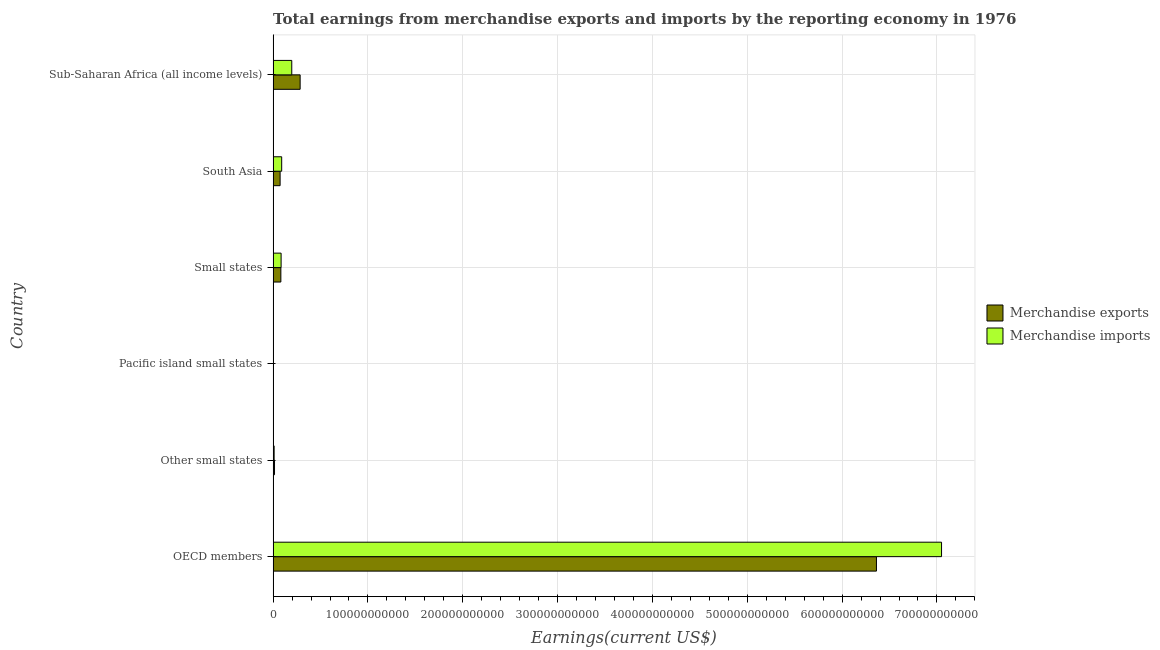How many different coloured bars are there?
Keep it short and to the point. 2. Are the number of bars per tick equal to the number of legend labels?
Make the answer very short. Yes. How many bars are there on the 5th tick from the bottom?
Ensure brevity in your answer.  2. In how many cases, is the number of bars for a given country not equal to the number of legend labels?
Your answer should be compact. 0. What is the earnings from merchandise imports in Small states?
Your answer should be compact. 8.42e+09. Across all countries, what is the maximum earnings from merchandise imports?
Offer a terse response. 7.05e+11. Across all countries, what is the minimum earnings from merchandise exports?
Offer a terse response. 1.87e+08. In which country was the earnings from merchandise imports minimum?
Offer a very short reply. Pacific island small states. What is the total earnings from merchandise exports in the graph?
Keep it short and to the point. 6.82e+11. What is the difference between the earnings from merchandise imports in OECD members and that in South Asia?
Ensure brevity in your answer.  6.96e+11. What is the difference between the earnings from merchandise imports in South Asia and the earnings from merchandise exports in Sub-Saharan Africa (all income levels)?
Provide a succinct answer. -1.95e+1. What is the average earnings from merchandise imports per country?
Provide a short and direct response. 1.24e+11. What is the difference between the earnings from merchandise imports and earnings from merchandise exports in Sub-Saharan Africa (all income levels)?
Ensure brevity in your answer.  -8.84e+09. In how many countries, is the earnings from merchandise imports greater than 280000000000 US$?
Offer a very short reply. 1. What is the ratio of the earnings from merchandise exports in Other small states to that in Sub-Saharan Africa (all income levels)?
Offer a very short reply. 0.05. Is the earnings from merchandise imports in OECD members less than that in Small states?
Your answer should be compact. No. What is the difference between the highest and the second highest earnings from merchandise exports?
Your answer should be compact. 6.08e+11. What is the difference between the highest and the lowest earnings from merchandise exports?
Your response must be concise. 6.36e+11. In how many countries, is the earnings from merchandise imports greater than the average earnings from merchandise imports taken over all countries?
Offer a terse response. 1. Is the sum of the earnings from merchandise imports in Pacific island small states and Small states greater than the maximum earnings from merchandise exports across all countries?
Your answer should be very brief. No. What does the 2nd bar from the top in South Asia represents?
Provide a short and direct response. Merchandise exports. What does the 2nd bar from the bottom in South Asia represents?
Your response must be concise. Merchandise imports. How many bars are there?
Keep it short and to the point. 12. Are all the bars in the graph horizontal?
Give a very brief answer. Yes. What is the difference between two consecutive major ticks on the X-axis?
Your answer should be compact. 1.00e+11. Does the graph contain any zero values?
Provide a succinct answer. No. How many legend labels are there?
Give a very brief answer. 2. What is the title of the graph?
Ensure brevity in your answer.  Total earnings from merchandise exports and imports by the reporting economy in 1976. Does "Non-resident workers" appear as one of the legend labels in the graph?
Ensure brevity in your answer.  No. What is the label or title of the X-axis?
Give a very brief answer. Earnings(current US$). What is the label or title of the Y-axis?
Offer a very short reply. Country. What is the Earnings(current US$) of Merchandise exports in OECD members?
Your answer should be very brief. 6.36e+11. What is the Earnings(current US$) in Merchandise imports in OECD members?
Make the answer very short. 7.05e+11. What is the Earnings(current US$) of Merchandise exports in Other small states?
Offer a very short reply. 1.46e+09. What is the Earnings(current US$) of Merchandise imports in Other small states?
Make the answer very short. 1.07e+09. What is the Earnings(current US$) of Merchandise exports in Pacific island small states?
Your answer should be very brief. 1.87e+08. What is the Earnings(current US$) of Merchandise imports in Pacific island small states?
Keep it short and to the point. 3.20e+08. What is the Earnings(current US$) of Merchandise exports in Small states?
Offer a very short reply. 8.16e+09. What is the Earnings(current US$) in Merchandise imports in Small states?
Give a very brief answer. 8.42e+09. What is the Earnings(current US$) in Merchandise exports in South Asia?
Provide a succinct answer. 7.37e+09. What is the Earnings(current US$) in Merchandise imports in South Asia?
Keep it short and to the point. 9.03e+09. What is the Earnings(current US$) in Merchandise exports in Sub-Saharan Africa (all income levels)?
Ensure brevity in your answer.  2.85e+1. What is the Earnings(current US$) of Merchandise imports in Sub-Saharan Africa (all income levels)?
Make the answer very short. 1.97e+1. Across all countries, what is the maximum Earnings(current US$) of Merchandise exports?
Provide a short and direct response. 6.36e+11. Across all countries, what is the maximum Earnings(current US$) of Merchandise imports?
Your answer should be very brief. 7.05e+11. Across all countries, what is the minimum Earnings(current US$) of Merchandise exports?
Your response must be concise. 1.87e+08. Across all countries, what is the minimum Earnings(current US$) in Merchandise imports?
Offer a very short reply. 3.20e+08. What is the total Earnings(current US$) of Merchandise exports in the graph?
Keep it short and to the point. 6.82e+11. What is the total Earnings(current US$) of Merchandise imports in the graph?
Give a very brief answer. 7.43e+11. What is the difference between the Earnings(current US$) in Merchandise exports in OECD members and that in Other small states?
Give a very brief answer. 6.35e+11. What is the difference between the Earnings(current US$) in Merchandise imports in OECD members and that in Other small states?
Keep it short and to the point. 7.04e+11. What is the difference between the Earnings(current US$) in Merchandise exports in OECD members and that in Pacific island small states?
Keep it short and to the point. 6.36e+11. What is the difference between the Earnings(current US$) in Merchandise imports in OECD members and that in Pacific island small states?
Provide a short and direct response. 7.05e+11. What is the difference between the Earnings(current US$) in Merchandise exports in OECD members and that in Small states?
Keep it short and to the point. 6.28e+11. What is the difference between the Earnings(current US$) in Merchandise imports in OECD members and that in Small states?
Provide a succinct answer. 6.96e+11. What is the difference between the Earnings(current US$) of Merchandise exports in OECD members and that in South Asia?
Keep it short and to the point. 6.29e+11. What is the difference between the Earnings(current US$) of Merchandise imports in OECD members and that in South Asia?
Your response must be concise. 6.96e+11. What is the difference between the Earnings(current US$) of Merchandise exports in OECD members and that in Sub-Saharan Africa (all income levels)?
Your answer should be very brief. 6.08e+11. What is the difference between the Earnings(current US$) in Merchandise imports in OECD members and that in Sub-Saharan Africa (all income levels)?
Keep it short and to the point. 6.85e+11. What is the difference between the Earnings(current US$) of Merchandise exports in Other small states and that in Pacific island small states?
Offer a very short reply. 1.28e+09. What is the difference between the Earnings(current US$) in Merchandise imports in Other small states and that in Pacific island small states?
Provide a succinct answer. 7.48e+08. What is the difference between the Earnings(current US$) in Merchandise exports in Other small states and that in Small states?
Give a very brief answer. -6.69e+09. What is the difference between the Earnings(current US$) in Merchandise imports in Other small states and that in Small states?
Your answer should be very brief. -7.36e+09. What is the difference between the Earnings(current US$) in Merchandise exports in Other small states and that in South Asia?
Your response must be concise. -5.91e+09. What is the difference between the Earnings(current US$) in Merchandise imports in Other small states and that in South Asia?
Your answer should be compact. -7.96e+09. What is the difference between the Earnings(current US$) of Merchandise exports in Other small states and that in Sub-Saharan Africa (all income levels)?
Your answer should be compact. -2.70e+1. What is the difference between the Earnings(current US$) of Merchandise imports in Other small states and that in Sub-Saharan Africa (all income levels)?
Your answer should be very brief. -1.86e+1. What is the difference between the Earnings(current US$) in Merchandise exports in Pacific island small states and that in Small states?
Your response must be concise. -7.97e+09. What is the difference between the Earnings(current US$) in Merchandise imports in Pacific island small states and that in Small states?
Provide a succinct answer. -8.10e+09. What is the difference between the Earnings(current US$) of Merchandise exports in Pacific island small states and that in South Asia?
Provide a succinct answer. -7.18e+09. What is the difference between the Earnings(current US$) in Merchandise imports in Pacific island small states and that in South Asia?
Keep it short and to the point. -8.71e+09. What is the difference between the Earnings(current US$) of Merchandise exports in Pacific island small states and that in Sub-Saharan Africa (all income levels)?
Provide a succinct answer. -2.83e+1. What is the difference between the Earnings(current US$) in Merchandise imports in Pacific island small states and that in Sub-Saharan Africa (all income levels)?
Give a very brief answer. -1.93e+1. What is the difference between the Earnings(current US$) in Merchandise exports in Small states and that in South Asia?
Your response must be concise. 7.84e+08. What is the difference between the Earnings(current US$) in Merchandise imports in Small states and that in South Asia?
Give a very brief answer. -6.01e+08. What is the difference between the Earnings(current US$) of Merchandise exports in Small states and that in Sub-Saharan Africa (all income levels)?
Provide a short and direct response. -2.03e+1. What is the difference between the Earnings(current US$) of Merchandise imports in Small states and that in Sub-Saharan Africa (all income levels)?
Your answer should be very brief. -1.12e+1. What is the difference between the Earnings(current US$) of Merchandise exports in South Asia and that in Sub-Saharan Africa (all income levels)?
Your response must be concise. -2.11e+1. What is the difference between the Earnings(current US$) in Merchandise imports in South Asia and that in Sub-Saharan Africa (all income levels)?
Your answer should be compact. -1.06e+1. What is the difference between the Earnings(current US$) in Merchandise exports in OECD members and the Earnings(current US$) in Merchandise imports in Other small states?
Offer a very short reply. 6.35e+11. What is the difference between the Earnings(current US$) of Merchandise exports in OECD members and the Earnings(current US$) of Merchandise imports in Pacific island small states?
Provide a succinct answer. 6.36e+11. What is the difference between the Earnings(current US$) of Merchandise exports in OECD members and the Earnings(current US$) of Merchandise imports in Small states?
Your answer should be compact. 6.28e+11. What is the difference between the Earnings(current US$) in Merchandise exports in OECD members and the Earnings(current US$) in Merchandise imports in South Asia?
Your answer should be compact. 6.27e+11. What is the difference between the Earnings(current US$) of Merchandise exports in OECD members and the Earnings(current US$) of Merchandise imports in Sub-Saharan Africa (all income levels)?
Your answer should be compact. 6.17e+11. What is the difference between the Earnings(current US$) in Merchandise exports in Other small states and the Earnings(current US$) in Merchandise imports in Pacific island small states?
Your answer should be very brief. 1.14e+09. What is the difference between the Earnings(current US$) in Merchandise exports in Other small states and the Earnings(current US$) in Merchandise imports in Small states?
Provide a short and direct response. -6.96e+09. What is the difference between the Earnings(current US$) in Merchandise exports in Other small states and the Earnings(current US$) in Merchandise imports in South Asia?
Keep it short and to the point. -7.56e+09. What is the difference between the Earnings(current US$) of Merchandise exports in Other small states and the Earnings(current US$) of Merchandise imports in Sub-Saharan Africa (all income levels)?
Give a very brief answer. -1.82e+1. What is the difference between the Earnings(current US$) of Merchandise exports in Pacific island small states and the Earnings(current US$) of Merchandise imports in Small states?
Offer a terse response. -8.24e+09. What is the difference between the Earnings(current US$) in Merchandise exports in Pacific island small states and the Earnings(current US$) in Merchandise imports in South Asia?
Your answer should be compact. -8.84e+09. What is the difference between the Earnings(current US$) of Merchandise exports in Pacific island small states and the Earnings(current US$) of Merchandise imports in Sub-Saharan Africa (all income levels)?
Provide a succinct answer. -1.95e+1. What is the difference between the Earnings(current US$) of Merchandise exports in Small states and the Earnings(current US$) of Merchandise imports in South Asia?
Your answer should be very brief. -8.70e+08. What is the difference between the Earnings(current US$) in Merchandise exports in Small states and the Earnings(current US$) in Merchandise imports in Sub-Saharan Africa (all income levels)?
Ensure brevity in your answer.  -1.15e+1. What is the difference between the Earnings(current US$) of Merchandise exports in South Asia and the Earnings(current US$) of Merchandise imports in Sub-Saharan Africa (all income levels)?
Your response must be concise. -1.23e+1. What is the average Earnings(current US$) in Merchandise exports per country?
Provide a short and direct response. 1.14e+11. What is the average Earnings(current US$) of Merchandise imports per country?
Your answer should be very brief. 1.24e+11. What is the difference between the Earnings(current US$) in Merchandise exports and Earnings(current US$) in Merchandise imports in OECD members?
Ensure brevity in your answer.  -6.86e+1. What is the difference between the Earnings(current US$) of Merchandise exports and Earnings(current US$) of Merchandise imports in Other small states?
Your response must be concise. 3.96e+08. What is the difference between the Earnings(current US$) in Merchandise exports and Earnings(current US$) in Merchandise imports in Pacific island small states?
Ensure brevity in your answer.  -1.33e+08. What is the difference between the Earnings(current US$) of Merchandise exports and Earnings(current US$) of Merchandise imports in Small states?
Your response must be concise. -2.69e+08. What is the difference between the Earnings(current US$) in Merchandise exports and Earnings(current US$) in Merchandise imports in South Asia?
Ensure brevity in your answer.  -1.65e+09. What is the difference between the Earnings(current US$) in Merchandise exports and Earnings(current US$) in Merchandise imports in Sub-Saharan Africa (all income levels)?
Provide a short and direct response. 8.84e+09. What is the ratio of the Earnings(current US$) of Merchandise exports in OECD members to that in Other small states?
Make the answer very short. 434.72. What is the ratio of the Earnings(current US$) of Merchandise imports in OECD members to that in Other small states?
Your answer should be very brief. 660.09. What is the ratio of the Earnings(current US$) of Merchandise exports in OECD members to that in Pacific island small states?
Make the answer very short. 3403.96. What is the ratio of the Earnings(current US$) in Merchandise imports in OECD members to that in Pacific island small states?
Your response must be concise. 2204.43. What is the ratio of the Earnings(current US$) in Merchandise exports in OECD members to that in Small states?
Keep it short and to the point. 78.01. What is the ratio of the Earnings(current US$) of Merchandise imports in OECD members to that in Small states?
Your answer should be compact. 83.66. What is the ratio of the Earnings(current US$) of Merchandise exports in OECD members to that in South Asia?
Make the answer very short. 86.31. What is the ratio of the Earnings(current US$) in Merchandise imports in OECD members to that in South Asia?
Provide a short and direct response. 78.09. What is the ratio of the Earnings(current US$) in Merchandise exports in OECD members to that in Sub-Saharan Africa (all income levels)?
Keep it short and to the point. 22.33. What is the ratio of the Earnings(current US$) of Merchandise imports in OECD members to that in Sub-Saharan Africa (all income levels)?
Give a very brief answer. 35.87. What is the ratio of the Earnings(current US$) in Merchandise exports in Other small states to that in Pacific island small states?
Your answer should be very brief. 7.83. What is the ratio of the Earnings(current US$) of Merchandise imports in Other small states to that in Pacific island small states?
Make the answer very short. 3.34. What is the ratio of the Earnings(current US$) in Merchandise exports in Other small states to that in Small states?
Keep it short and to the point. 0.18. What is the ratio of the Earnings(current US$) in Merchandise imports in Other small states to that in Small states?
Your answer should be very brief. 0.13. What is the ratio of the Earnings(current US$) of Merchandise exports in Other small states to that in South Asia?
Provide a short and direct response. 0.2. What is the ratio of the Earnings(current US$) in Merchandise imports in Other small states to that in South Asia?
Provide a short and direct response. 0.12. What is the ratio of the Earnings(current US$) in Merchandise exports in Other small states to that in Sub-Saharan Africa (all income levels)?
Make the answer very short. 0.05. What is the ratio of the Earnings(current US$) of Merchandise imports in Other small states to that in Sub-Saharan Africa (all income levels)?
Keep it short and to the point. 0.05. What is the ratio of the Earnings(current US$) in Merchandise exports in Pacific island small states to that in Small states?
Keep it short and to the point. 0.02. What is the ratio of the Earnings(current US$) of Merchandise imports in Pacific island small states to that in Small states?
Give a very brief answer. 0.04. What is the ratio of the Earnings(current US$) of Merchandise exports in Pacific island small states to that in South Asia?
Keep it short and to the point. 0.03. What is the ratio of the Earnings(current US$) of Merchandise imports in Pacific island small states to that in South Asia?
Your answer should be compact. 0.04. What is the ratio of the Earnings(current US$) of Merchandise exports in Pacific island small states to that in Sub-Saharan Africa (all income levels)?
Provide a short and direct response. 0.01. What is the ratio of the Earnings(current US$) of Merchandise imports in Pacific island small states to that in Sub-Saharan Africa (all income levels)?
Offer a terse response. 0.02. What is the ratio of the Earnings(current US$) of Merchandise exports in Small states to that in South Asia?
Make the answer very short. 1.11. What is the ratio of the Earnings(current US$) in Merchandise imports in Small states to that in South Asia?
Make the answer very short. 0.93. What is the ratio of the Earnings(current US$) in Merchandise exports in Small states to that in Sub-Saharan Africa (all income levels)?
Make the answer very short. 0.29. What is the ratio of the Earnings(current US$) of Merchandise imports in Small states to that in Sub-Saharan Africa (all income levels)?
Make the answer very short. 0.43. What is the ratio of the Earnings(current US$) in Merchandise exports in South Asia to that in Sub-Saharan Africa (all income levels)?
Provide a short and direct response. 0.26. What is the ratio of the Earnings(current US$) of Merchandise imports in South Asia to that in Sub-Saharan Africa (all income levels)?
Make the answer very short. 0.46. What is the difference between the highest and the second highest Earnings(current US$) of Merchandise exports?
Give a very brief answer. 6.08e+11. What is the difference between the highest and the second highest Earnings(current US$) in Merchandise imports?
Your response must be concise. 6.85e+11. What is the difference between the highest and the lowest Earnings(current US$) in Merchandise exports?
Your answer should be very brief. 6.36e+11. What is the difference between the highest and the lowest Earnings(current US$) of Merchandise imports?
Offer a terse response. 7.05e+11. 